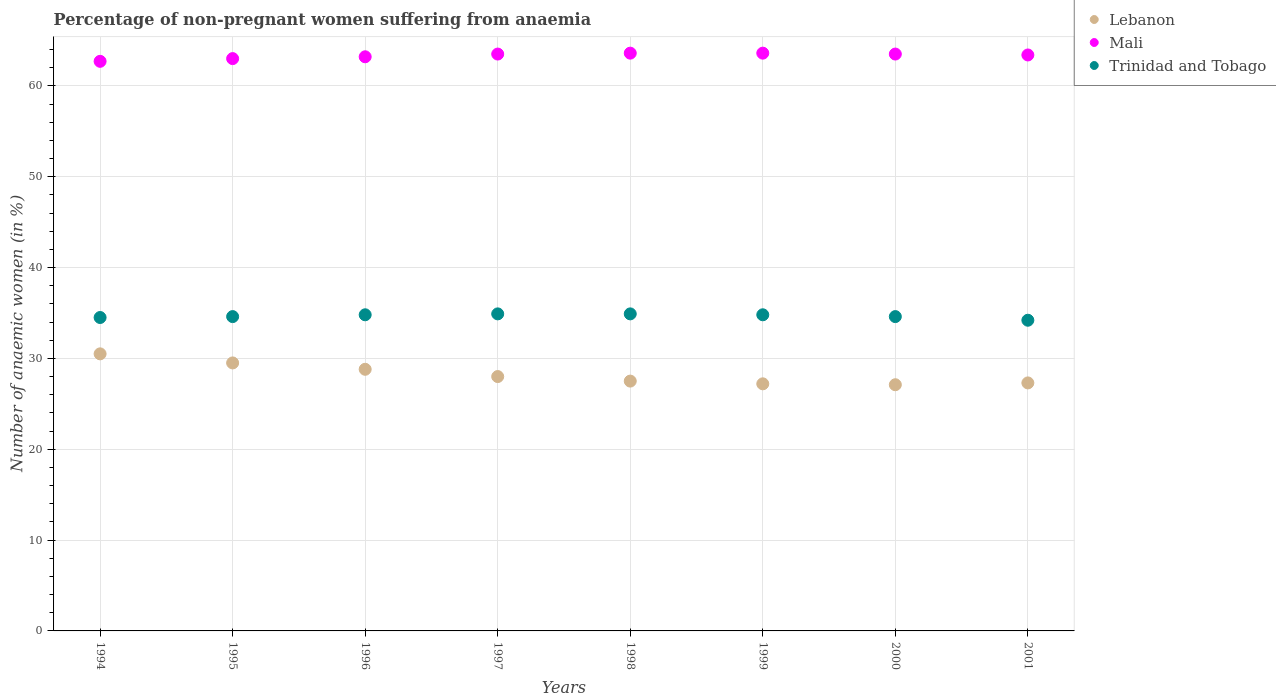What is the percentage of non-pregnant women suffering from anaemia in Lebanon in 2001?
Your response must be concise. 27.3. Across all years, what is the maximum percentage of non-pregnant women suffering from anaemia in Lebanon?
Provide a succinct answer. 30.5. Across all years, what is the minimum percentage of non-pregnant women suffering from anaemia in Trinidad and Tobago?
Ensure brevity in your answer.  34.2. What is the total percentage of non-pregnant women suffering from anaemia in Mali in the graph?
Your answer should be compact. 506.5. What is the difference between the percentage of non-pregnant women suffering from anaemia in Mali in 2000 and that in 2001?
Provide a succinct answer. 0.1. What is the difference between the percentage of non-pregnant women suffering from anaemia in Mali in 1994 and the percentage of non-pregnant women suffering from anaemia in Trinidad and Tobago in 1996?
Offer a terse response. 27.9. What is the average percentage of non-pregnant women suffering from anaemia in Mali per year?
Give a very brief answer. 63.31. In the year 1998, what is the difference between the percentage of non-pregnant women suffering from anaemia in Mali and percentage of non-pregnant women suffering from anaemia in Lebanon?
Offer a very short reply. 36.1. In how many years, is the percentage of non-pregnant women suffering from anaemia in Lebanon greater than 10 %?
Provide a short and direct response. 8. What is the ratio of the percentage of non-pregnant women suffering from anaemia in Lebanon in 1995 to that in 1996?
Ensure brevity in your answer.  1.02. Is the percentage of non-pregnant women suffering from anaemia in Lebanon in 1999 less than that in 2000?
Keep it short and to the point. No. What is the difference between the highest and the second highest percentage of non-pregnant women suffering from anaemia in Mali?
Give a very brief answer. 0. What is the difference between the highest and the lowest percentage of non-pregnant women suffering from anaemia in Mali?
Your answer should be compact. 0.9. Is the sum of the percentage of non-pregnant women suffering from anaemia in Trinidad and Tobago in 1995 and 1996 greater than the maximum percentage of non-pregnant women suffering from anaemia in Lebanon across all years?
Your answer should be compact. Yes. Does the percentage of non-pregnant women suffering from anaemia in Lebanon monotonically increase over the years?
Provide a short and direct response. No. Is the percentage of non-pregnant women suffering from anaemia in Mali strictly less than the percentage of non-pregnant women suffering from anaemia in Lebanon over the years?
Your response must be concise. No. How many dotlines are there?
Provide a succinct answer. 3. How many years are there in the graph?
Keep it short and to the point. 8. Does the graph contain any zero values?
Your answer should be very brief. No. Where does the legend appear in the graph?
Provide a succinct answer. Top right. How many legend labels are there?
Ensure brevity in your answer.  3. How are the legend labels stacked?
Offer a terse response. Vertical. What is the title of the graph?
Ensure brevity in your answer.  Percentage of non-pregnant women suffering from anaemia. What is the label or title of the X-axis?
Make the answer very short. Years. What is the label or title of the Y-axis?
Offer a terse response. Number of anaemic women (in %). What is the Number of anaemic women (in %) of Lebanon in 1994?
Keep it short and to the point. 30.5. What is the Number of anaemic women (in %) in Mali in 1994?
Ensure brevity in your answer.  62.7. What is the Number of anaemic women (in %) of Trinidad and Tobago in 1994?
Offer a terse response. 34.5. What is the Number of anaemic women (in %) in Lebanon in 1995?
Your answer should be very brief. 29.5. What is the Number of anaemic women (in %) in Trinidad and Tobago in 1995?
Make the answer very short. 34.6. What is the Number of anaemic women (in %) in Lebanon in 1996?
Your response must be concise. 28.8. What is the Number of anaemic women (in %) in Mali in 1996?
Your response must be concise. 63.2. What is the Number of anaemic women (in %) in Trinidad and Tobago in 1996?
Provide a succinct answer. 34.8. What is the Number of anaemic women (in %) of Mali in 1997?
Give a very brief answer. 63.5. What is the Number of anaemic women (in %) in Trinidad and Tobago in 1997?
Your answer should be compact. 34.9. What is the Number of anaemic women (in %) of Lebanon in 1998?
Your answer should be compact. 27.5. What is the Number of anaemic women (in %) of Mali in 1998?
Give a very brief answer. 63.6. What is the Number of anaemic women (in %) of Trinidad and Tobago in 1998?
Provide a short and direct response. 34.9. What is the Number of anaemic women (in %) in Lebanon in 1999?
Provide a short and direct response. 27.2. What is the Number of anaemic women (in %) in Mali in 1999?
Provide a succinct answer. 63.6. What is the Number of anaemic women (in %) in Trinidad and Tobago in 1999?
Ensure brevity in your answer.  34.8. What is the Number of anaemic women (in %) of Lebanon in 2000?
Ensure brevity in your answer.  27.1. What is the Number of anaemic women (in %) of Mali in 2000?
Keep it short and to the point. 63.5. What is the Number of anaemic women (in %) in Trinidad and Tobago in 2000?
Keep it short and to the point. 34.6. What is the Number of anaemic women (in %) of Lebanon in 2001?
Give a very brief answer. 27.3. What is the Number of anaemic women (in %) in Mali in 2001?
Offer a terse response. 63.4. What is the Number of anaemic women (in %) in Trinidad and Tobago in 2001?
Offer a very short reply. 34.2. Across all years, what is the maximum Number of anaemic women (in %) in Lebanon?
Ensure brevity in your answer.  30.5. Across all years, what is the maximum Number of anaemic women (in %) in Mali?
Make the answer very short. 63.6. Across all years, what is the maximum Number of anaemic women (in %) in Trinidad and Tobago?
Your response must be concise. 34.9. Across all years, what is the minimum Number of anaemic women (in %) of Lebanon?
Your response must be concise. 27.1. Across all years, what is the minimum Number of anaemic women (in %) of Mali?
Ensure brevity in your answer.  62.7. Across all years, what is the minimum Number of anaemic women (in %) of Trinidad and Tobago?
Your response must be concise. 34.2. What is the total Number of anaemic women (in %) of Lebanon in the graph?
Keep it short and to the point. 225.9. What is the total Number of anaemic women (in %) in Mali in the graph?
Your answer should be compact. 506.5. What is the total Number of anaemic women (in %) of Trinidad and Tobago in the graph?
Your answer should be very brief. 277.3. What is the difference between the Number of anaemic women (in %) in Lebanon in 1994 and that in 1996?
Your answer should be very brief. 1.7. What is the difference between the Number of anaemic women (in %) in Trinidad and Tobago in 1994 and that in 1996?
Your answer should be compact. -0.3. What is the difference between the Number of anaemic women (in %) in Lebanon in 1994 and that in 1997?
Offer a very short reply. 2.5. What is the difference between the Number of anaemic women (in %) of Mali in 1994 and that in 1997?
Your response must be concise. -0.8. What is the difference between the Number of anaemic women (in %) in Trinidad and Tobago in 1994 and that in 1997?
Ensure brevity in your answer.  -0.4. What is the difference between the Number of anaemic women (in %) of Lebanon in 1994 and that in 1998?
Ensure brevity in your answer.  3. What is the difference between the Number of anaemic women (in %) of Mali in 1994 and that in 1998?
Ensure brevity in your answer.  -0.9. What is the difference between the Number of anaemic women (in %) in Lebanon in 1994 and that in 2000?
Ensure brevity in your answer.  3.4. What is the difference between the Number of anaemic women (in %) of Mali in 1994 and that in 2000?
Offer a terse response. -0.8. What is the difference between the Number of anaemic women (in %) in Trinidad and Tobago in 1994 and that in 2000?
Your answer should be compact. -0.1. What is the difference between the Number of anaemic women (in %) in Trinidad and Tobago in 1994 and that in 2001?
Your response must be concise. 0.3. What is the difference between the Number of anaemic women (in %) of Lebanon in 1995 and that in 1996?
Your answer should be very brief. 0.7. What is the difference between the Number of anaemic women (in %) in Lebanon in 1995 and that in 1997?
Provide a short and direct response. 1.5. What is the difference between the Number of anaemic women (in %) in Mali in 1995 and that in 1997?
Offer a very short reply. -0.5. What is the difference between the Number of anaemic women (in %) in Lebanon in 1995 and that in 1998?
Offer a terse response. 2. What is the difference between the Number of anaemic women (in %) in Trinidad and Tobago in 1995 and that in 1998?
Ensure brevity in your answer.  -0.3. What is the difference between the Number of anaemic women (in %) in Lebanon in 1995 and that in 1999?
Make the answer very short. 2.3. What is the difference between the Number of anaemic women (in %) in Mali in 1995 and that in 2000?
Your answer should be compact. -0.5. What is the difference between the Number of anaemic women (in %) in Trinidad and Tobago in 1995 and that in 2001?
Provide a succinct answer. 0.4. What is the difference between the Number of anaemic women (in %) of Lebanon in 1996 and that in 1997?
Keep it short and to the point. 0.8. What is the difference between the Number of anaemic women (in %) in Trinidad and Tobago in 1996 and that in 1997?
Your answer should be compact. -0.1. What is the difference between the Number of anaemic women (in %) of Mali in 1996 and that in 1998?
Give a very brief answer. -0.4. What is the difference between the Number of anaemic women (in %) in Trinidad and Tobago in 1996 and that in 1998?
Provide a succinct answer. -0.1. What is the difference between the Number of anaemic women (in %) of Mali in 1996 and that in 1999?
Ensure brevity in your answer.  -0.4. What is the difference between the Number of anaemic women (in %) of Mali in 1996 and that in 2000?
Provide a succinct answer. -0.3. What is the difference between the Number of anaemic women (in %) in Trinidad and Tobago in 1996 and that in 2000?
Offer a terse response. 0.2. What is the difference between the Number of anaemic women (in %) of Lebanon in 1997 and that in 1998?
Give a very brief answer. 0.5. What is the difference between the Number of anaemic women (in %) in Mali in 1997 and that in 1998?
Make the answer very short. -0.1. What is the difference between the Number of anaemic women (in %) of Lebanon in 1997 and that in 1999?
Your answer should be compact. 0.8. What is the difference between the Number of anaemic women (in %) of Mali in 1997 and that in 2000?
Give a very brief answer. 0. What is the difference between the Number of anaemic women (in %) of Lebanon in 1997 and that in 2001?
Your response must be concise. 0.7. What is the difference between the Number of anaemic women (in %) of Trinidad and Tobago in 1997 and that in 2001?
Make the answer very short. 0.7. What is the difference between the Number of anaemic women (in %) in Lebanon in 1998 and that in 1999?
Your answer should be compact. 0.3. What is the difference between the Number of anaemic women (in %) of Mali in 1998 and that in 2001?
Your answer should be compact. 0.2. What is the difference between the Number of anaemic women (in %) in Trinidad and Tobago in 1998 and that in 2001?
Provide a short and direct response. 0.7. What is the difference between the Number of anaemic women (in %) in Mali in 1999 and that in 2000?
Give a very brief answer. 0.1. What is the difference between the Number of anaemic women (in %) in Lebanon in 1994 and the Number of anaemic women (in %) in Mali in 1995?
Provide a short and direct response. -32.5. What is the difference between the Number of anaemic women (in %) in Mali in 1994 and the Number of anaemic women (in %) in Trinidad and Tobago in 1995?
Your response must be concise. 28.1. What is the difference between the Number of anaemic women (in %) in Lebanon in 1994 and the Number of anaemic women (in %) in Mali in 1996?
Your response must be concise. -32.7. What is the difference between the Number of anaemic women (in %) in Lebanon in 1994 and the Number of anaemic women (in %) in Trinidad and Tobago in 1996?
Offer a terse response. -4.3. What is the difference between the Number of anaemic women (in %) of Mali in 1994 and the Number of anaemic women (in %) of Trinidad and Tobago in 1996?
Offer a very short reply. 27.9. What is the difference between the Number of anaemic women (in %) of Lebanon in 1994 and the Number of anaemic women (in %) of Mali in 1997?
Your response must be concise. -33. What is the difference between the Number of anaemic women (in %) of Mali in 1994 and the Number of anaemic women (in %) of Trinidad and Tobago in 1997?
Offer a terse response. 27.8. What is the difference between the Number of anaemic women (in %) of Lebanon in 1994 and the Number of anaemic women (in %) of Mali in 1998?
Keep it short and to the point. -33.1. What is the difference between the Number of anaemic women (in %) of Lebanon in 1994 and the Number of anaemic women (in %) of Trinidad and Tobago in 1998?
Keep it short and to the point. -4.4. What is the difference between the Number of anaemic women (in %) in Mali in 1994 and the Number of anaemic women (in %) in Trinidad and Tobago in 1998?
Your response must be concise. 27.8. What is the difference between the Number of anaemic women (in %) of Lebanon in 1994 and the Number of anaemic women (in %) of Mali in 1999?
Provide a short and direct response. -33.1. What is the difference between the Number of anaemic women (in %) of Mali in 1994 and the Number of anaemic women (in %) of Trinidad and Tobago in 1999?
Your response must be concise. 27.9. What is the difference between the Number of anaemic women (in %) of Lebanon in 1994 and the Number of anaemic women (in %) of Mali in 2000?
Your answer should be compact. -33. What is the difference between the Number of anaemic women (in %) in Lebanon in 1994 and the Number of anaemic women (in %) in Trinidad and Tobago in 2000?
Make the answer very short. -4.1. What is the difference between the Number of anaemic women (in %) in Mali in 1994 and the Number of anaemic women (in %) in Trinidad and Tobago in 2000?
Provide a succinct answer. 28.1. What is the difference between the Number of anaemic women (in %) of Lebanon in 1994 and the Number of anaemic women (in %) of Mali in 2001?
Your response must be concise. -32.9. What is the difference between the Number of anaemic women (in %) in Lebanon in 1994 and the Number of anaemic women (in %) in Trinidad and Tobago in 2001?
Your answer should be compact. -3.7. What is the difference between the Number of anaemic women (in %) of Mali in 1994 and the Number of anaemic women (in %) of Trinidad and Tobago in 2001?
Make the answer very short. 28.5. What is the difference between the Number of anaemic women (in %) in Lebanon in 1995 and the Number of anaemic women (in %) in Mali in 1996?
Make the answer very short. -33.7. What is the difference between the Number of anaemic women (in %) of Mali in 1995 and the Number of anaemic women (in %) of Trinidad and Tobago in 1996?
Your answer should be compact. 28.2. What is the difference between the Number of anaemic women (in %) of Lebanon in 1995 and the Number of anaemic women (in %) of Mali in 1997?
Your response must be concise. -34. What is the difference between the Number of anaemic women (in %) of Mali in 1995 and the Number of anaemic women (in %) of Trinidad and Tobago in 1997?
Make the answer very short. 28.1. What is the difference between the Number of anaemic women (in %) of Lebanon in 1995 and the Number of anaemic women (in %) of Mali in 1998?
Provide a succinct answer. -34.1. What is the difference between the Number of anaemic women (in %) of Lebanon in 1995 and the Number of anaemic women (in %) of Trinidad and Tobago in 1998?
Offer a terse response. -5.4. What is the difference between the Number of anaemic women (in %) of Mali in 1995 and the Number of anaemic women (in %) of Trinidad and Tobago in 1998?
Your response must be concise. 28.1. What is the difference between the Number of anaemic women (in %) of Lebanon in 1995 and the Number of anaemic women (in %) of Mali in 1999?
Ensure brevity in your answer.  -34.1. What is the difference between the Number of anaemic women (in %) of Lebanon in 1995 and the Number of anaemic women (in %) of Trinidad and Tobago in 1999?
Provide a short and direct response. -5.3. What is the difference between the Number of anaemic women (in %) of Mali in 1995 and the Number of anaemic women (in %) of Trinidad and Tobago in 1999?
Provide a succinct answer. 28.2. What is the difference between the Number of anaemic women (in %) of Lebanon in 1995 and the Number of anaemic women (in %) of Mali in 2000?
Offer a terse response. -34. What is the difference between the Number of anaemic women (in %) of Lebanon in 1995 and the Number of anaemic women (in %) of Trinidad and Tobago in 2000?
Offer a very short reply. -5.1. What is the difference between the Number of anaemic women (in %) in Mali in 1995 and the Number of anaemic women (in %) in Trinidad and Tobago in 2000?
Your response must be concise. 28.4. What is the difference between the Number of anaemic women (in %) of Lebanon in 1995 and the Number of anaemic women (in %) of Mali in 2001?
Your answer should be compact. -33.9. What is the difference between the Number of anaemic women (in %) in Lebanon in 1995 and the Number of anaemic women (in %) in Trinidad and Tobago in 2001?
Your answer should be compact. -4.7. What is the difference between the Number of anaemic women (in %) of Mali in 1995 and the Number of anaemic women (in %) of Trinidad and Tobago in 2001?
Keep it short and to the point. 28.8. What is the difference between the Number of anaemic women (in %) in Lebanon in 1996 and the Number of anaemic women (in %) in Mali in 1997?
Provide a succinct answer. -34.7. What is the difference between the Number of anaemic women (in %) in Mali in 1996 and the Number of anaemic women (in %) in Trinidad and Tobago in 1997?
Your response must be concise. 28.3. What is the difference between the Number of anaemic women (in %) in Lebanon in 1996 and the Number of anaemic women (in %) in Mali in 1998?
Your response must be concise. -34.8. What is the difference between the Number of anaemic women (in %) in Lebanon in 1996 and the Number of anaemic women (in %) in Trinidad and Tobago in 1998?
Provide a succinct answer. -6.1. What is the difference between the Number of anaemic women (in %) in Mali in 1996 and the Number of anaemic women (in %) in Trinidad and Tobago in 1998?
Your answer should be compact. 28.3. What is the difference between the Number of anaemic women (in %) in Lebanon in 1996 and the Number of anaemic women (in %) in Mali in 1999?
Your answer should be very brief. -34.8. What is the difference between the Number of anaemic women (in %) of Mali in 1996 and the Number of anaemic women (in %) of Trinidad and Tobago in 1999?
Your answer should be compact. 28.4. What is the difference between the Number of anaemic women (in %) of Lebanon in 1996 and the Number of anaemic women (in %) of Mali in 2000?
Provide a succinct answer. -34.7. What is the difference between the Number of anaemic women (in %) in Lebanon in 1996 and the Number of anaemic women (in %) in Trinidad and Tobago in 2000?
Provide a succinct answer. -5.8. What is the difference between the Number of anaemic women (in %) in Mali in 1996 and the Number of anaemic women (in %) in Trinidad and Tobago in 2000?
Keep it short and to the point. 28.6. What is the difference between the Number of anaemic women (in %) of Lebanon in 1996 and the Number of anaemic women (in %) of Mali in 2001?
Offer a very short reply. -34.6. What is the difference between the Number of anaemic women (in %) of Lebanon in 1996 and the Number of anaemic women (in %) of Trinidad and Tobago in 2001?
Make the answer very short. -5.4. What is the difference between the Number of anaemic women (in %) in Lebanon in 1997 and the Number of anaemic women (in %) in Mali in 1998?
Offer a terse response. -35.6. What is the difference between the Number of anaemic women (in %) in Lebanon in 1997 and the Number of anaemic women (in %) in Trinidad and Tobago in 1998?
Your answer should be compact. -6.9. What is the difference between the Number of anaemic women (in %) of Mali in 1997 and the Number of anaemic women (in %) of Trinidad and Tobago in 1998?
Your answer should be compact. 28.6. What is the difference between the Number of anaemic women (in %) in Lebanon in 1997 and the Number of anaemic women (in %) in Mali in 1999?
Make the answer very short. -35.6. What is the difference between the Number of anaemic women (in %) of Lebanon in 1997 and the Number of anaemic women (in %) of Trinidad and Tobago in 1999?
Your answer should be very brief. -6.8. What is the difference between the Number of anaemic women (in %) in Mali in 1997 and the Number of anaemic women (in %) in Trinidad and Tobago in 1999?
Offer a terse response. 28.7. What is the difference between the Number of anaemic women (in %) in Lebanon in 1997 and the Number of anaemic women (in %) in Mali in 2000?
Provide a short and direct response. -35.5. What is the difference between the Number of anaemic women (in %) in Lebanon in 1997 and the Number of anaemic women (in %) in Trinidad and Tobago in 2000?
Your response must be concise. -6.6. What is the difference between the Number of anaemic women (in %) of Mali in 1997 and the Number of anaemic women (in %) of Trinidad and Tobago in 2000?
Give a very brief answer. 28.9. What is the difference between the Number of anaemic women (in %) in Lebanon in 1997 and the Number of anaemic women (in %) in Mali in 2001?
Your answer should be very brief. -35.4. What is the difference between the Number of anaemic women (in %) in Mali in 1997 and the Number of anaemic women (in %) in Trinidad and Tobago in 2001?
Provide a short and direct response. 29.3. What is the difference between the Number of anaemic women (in %) in Lebanon in 1998 and the Number of anaemic women (in %) in Mali in 1999?
Keep it short and to the point. -36.1. What is the difference between the Number of anaemic women (in %) in Mali in 1998 and the Number of anaemic women (in %) in Trinidad and Tobago in 1999?
Ensure brevity in your answer.  28.8. What is the difference between the Number of anaemic women (in %) in Lebanon in 1998 and the Number of anaemic women (in %) in Mali in 2000?
Your response must be concise. -36. What is the difference between the Number of anaemic women (in %) of Lebanon in 1998 and the Number of anaemic women (in %) of Trinidad and Tobago in 2000?
Your response must be concise. -7.1. What is the difference between the Number of anaemic women (in %) of Mali in 1998 and the Number of anaemic women (in %) of Trinidad and Tobago in 2000?
Give a very brief answer. 29. What is the difference between the Number of anaemic women (in %) of Lebanon in 1998 and the Number of anaemic women (in %) of Mali in 2001?
Offer a terse response. -35.9. What is the difference between the Number of anaemic women (in %) of Lebanon in 1998 and the Number of anaemic women (in %) of Trinidad and Tobago in 2001?
Make the answer very short. -6.7. What is the difference between the Number of anaemic women (in %) of Mali in 1998 and the Number of anaemic women (in %) of Trinidad and Tobago in 2001?
Your answer should be compact. 29.4. What is the difference between the Number of anaemic women (in %) of Lebanon in 1999 and the Number of anaemic women (in %) of Mali in 2000?
Your answer should be compact. -36.3. What is the difference between the Number of anaemic women (in %) of Lebanon in 1999 and the Number of anaemic women (in %) of Trinidad and Tobago in 2000?
Keep it short and to the point. -7.4. What is the difference between the Number of anaemic women (in %) of Lebanon in 1999 and the Number of anaemic women (in %) of Mali in 2001?
Your answer should be compact. -36.2. What is the difference between the Number of anaemic women (in %) in Mali in 1999 and the Number of anaemic women (in %) in Trinidad and Tobago in 2001?
Keep it short and to the point. 29.4. What is the difference between the Number of anaemic women (in %) in Lebanon in 2000 and the Number of anaemic women (in %) in Mali in 2001?
Your response must be concise. -36.3. What is the difference between the Number of anaemic women (in %) of Mali in 2000 and the Number of anaemic women (in %) of Trinidad and Tobago in 2001?
Provide a short and direct response. 29.3. What is the average Number of anaemic women (in %) in Lebanon per year?
Your response must be concise. 28.24. What is the average Number of anaemic women (in %) of Mali per year?
Keep it short and to the point. 63.31. What is the average Number of anaemic women (in %) of Trinidad and Tobago per year?
Ensure brevity in your answer.  34.66. In the year 1994, what is the difference between the Number of anaemic women (in %) of Lebanon and Number of anaemic women (in %) of Mali?
Provide a short and direct response. -32.2. In the year 1994, what is the difference between the Number of anaemic women (in %) of Lebanon and Number of anaemic women (in %) of Trinidad and Tobago?
Give a very brief answer. -4. In the year 1994, what is the difference between the Number of anaemic women (in %) in Mali and Number of anaemic women (in %) in Trinidad and Tobago?
Ensure brevity in your answer.  28.2. In the year 1995, what is the difference between the Number of anaemic women (in %) in Lebanon and Number of anaemic women (in %) in Mali?
Your answer should be compact. -33.5. In the year 1995, what is the difference between the Number of anaemic women (in %) of Mali and Number of anaemic women (in %) of Trinidad and Tobago?
Make the answer very short. 28.4. In the year 1996, what is the difference between the Number of anaemic women (in %) of Lebanon and Number of anaemic women (in %) of Mali?
Your answer should be compact. -34.4. In the year 1996, what is the difference between the Number of anaemic women (in %) of Lebanon and Number of anaemic women (in %) of Trinidad and Tobago?
Offer a very short reply. -6. In the year 1996, what is the difference between the Number of anaemic women (in %) in Mali and Number of anaemic women (in %) in Trinidad and Tobago?
Offer a very short reply. 28.4. In the year 1997, what is the difference between the Number of anaemic women (in %) of Lebanon and Number of anaemic women (in %) of Mali?
Give a very brief answer. -35.5. In the year 1997, what is the difference between the Number of anaemic women (in %) of Mali and Number of anaemic women (in %) of Trinidad and Tobago?
Ensure brevity in your answer.  28.6. In the year 1998, what is the difference between the Number of anaemic women (in %) in Lebanon and Number of anaemic women (in %) in Mali?
Make the answer very short. -36.1. In the year 1998, what is the difference between the Number of anaemic women (in %) of Mali and Number of anaemic women (in %) of Trinidad and Tobago?
Provide a short and direct response. 28.7. In the year 1999, what is the difference between the Number of anaemic women (in %) in Lebanon and Number of anaemic women (in %) in Mali?
Make the answer very short. -36.4. In the year 1999, what is the difference between the Number of anaemic women (in %) of Lebanon and Number of anaemic women (in %) of Trinidad and Tobago?
Your response must be concise. -7.6. In the year 1999, what is the difference between the Number of anaemic women (in %) of Mali and Number of anaemic women (in %) of Trinidad and Tobago?
Offer a terse response. 28.8. In the year 2000, what is the difference between the Number of anaemic women (in %) of Lebanon and Number of anaemic women (in %) of Mali?
Keep it short and to the point. -36.4. In the year 2000, what is the difference between the Number of anaemic women (in %) in Lebanon and Number of anaemic women (in %) in Trinidad and Tobago?
Make the answer very short. -7.5. In the year 2000, what is the difference between the Number of anaemic women (in %) of Mali and Number of anaemic women (in %) of Trinidad and Tobago?
Offer a terse response. 28.9. In the year 2001, what is the difference between the Number of anaemic women (in %) in Lebanon and Number of anaemic women (in %) in Mali?
Ensure brevity in your answer.  -36.1. In the year 2001, what is the difference between the Number of anaemic women (in %) of Lebanon and Number of anaemic women (in %) of Trinidad and Tobago?
Your response must be concise. -6.9. In the year 2001, what is the difference between the Number of anaemic women (in %) in Mali and Number of anaemic women (in %) in Trinidad and Tobago?
Your response must be concise. 29.2. What is the ratio of the Number of anaemic women (in %) in Lebanon in 1994 to that in 1995?
Your response must be concise. 1.03. What is the ratio of the Number of anaemic women (in %) of Trinidad and Tobago in 1994 to that in 1995?
Provide a short and direct response. 1. What is the ratio of the Number of anaemic women (in %) in Lebanon in 1994 to that in 1996?
Offer a very short reply. 1.06. What is the ratio of the Number of anaemic women (in %) of Trinidad and Tobago in 1994 to that in 1996?
Give a very brief answer. 0.99. What is the ratio of the Number of anaemic women (in %) of Lebanon in 1994 to that in 1997?
Your answer should be very brief. 1.09. What is the ratio of the Number of anaemic women (in %) of Mali in 1994 to that in 1997?
Your response must be concise. 0.99. What is the ratio of the Number of anaemic women (in %) of Trinidad and Tobago in 1994 to that in 1997?
Your answer should be very brief. 0.99. What is the ratio of the Number of anaemic women (in %) of Lebanon in 1994 to that in 1998?
Give a very brief answer. 1.11. What is the ratio of the Number of anaemic women (in %) of Mali in 1994 to that in 1998?
Your response must be concise. 0.99. What is the ratio of the Number of anaemic women (in %) of Trinidad and Tobago in 1994 to that in 1998?
Your answer should be compact. 0.99. What is the ratio of the Number of anaemic women (in %) in Lebanon in 1994 to that in 1999?
Your response must be concise. 1.12. What is the ratio of the Number of anaemic women (in %) in Mali in 1994 to that in 1999?
Your answer should be compact. 0.99. What is the ratio of the Number of anaemic women (in %) of Lebanon in 1994 to that in 2000?
Make the answer very short. 1.13. What is the ratio of the Number of anaemic women (in %) in Mali in 1994 to that in 2000?
Offer a very short reply. 0.99. What is the ratio of the Number of anaemic women (in %) in Lebanon in 1994 to that in 2001?
Your response must be concise. 1.12. What is the ratio of the Number of anaemic women (in %) in Mali in 1994 to that in 2001?
Your answer should be compact. 0.99. What is the ratio of the Number of anaemic women (in %) in Trinidad and Tobago in 1994 to that in 2001?
Your answer should be compact. 1.01. What is the ratio of the Number of anaemic women (in %) in Lebanon in 1995 to that in 1996?
Ensure brevity in your answer.  1.02. What is the ratio of the Number of anaemic women (in %) of Lebanon in 1995 to that in 1997?
Your answer should be compact. 1.05. What is the ratio of the Number of anaemic women (in %) of Mali in 1995 to that in 1997?
Ensure brevity in your answer.  0.99. What is the ratio of the Number of anaemic women (in %) in Trinidad and Tobago in 1995 to that in 1997?
Keep it short and to the point. 0.99. What is the ratio of the Number of anaemic women (in %) of Lebanon in 1995 to that in 1998?
Offer a terse response. 1.07. What is the ratio of the Number of anaemic women (in %) of Mali in 1995 to that in 1998?
Your answer should be compact. 0.99. What is the ratio of the Number of anaemic women (in %) in Trinidad and Tobago in 1995 to that in 1998?
Your answer should be compact. 0.99. What is the ratio of the Number of anaemic women (in %) in Lebanon in 1995 to that in 1999?
Your response must be concise. 1.08. What is the ratio of the Number of anaemic women (in %) of Mali in 1995 to that in 1999?
Give a very brief answer. 0.99. What is the ratio of the Number of anaemic women (in %) in Trinidad and Tobago in 1995 to that in 1999?
Offer a terse response. 0.99. What is the ratio of the Number of anaemic women (in %) of Lebanon in 1995 to that in 2000?
Your response must be concise. 1.09. What is the ratio of the Number of anaemic women (in %) in Mali in 1995 to that in 2000?
Your answer should be very brief. 0.99. What is the ratio of the Number of anaemic women (in %) of Lebanon in 1995 to that in 2001?
Provide a short and direct response. 1.08. What is the ratio of the Number of anaemic women (in %) of Mali in 1995 to that in 2001?
Provide a succinct answer. 0.99. What is the ratio of the Number of anaemic women (in %) of Trinidad and Tobago in 1995 to that in 2001?
Keep it short and to the point. 1.01. What is the ratio of the Number of anaemic women (in %) of Lebanon in 1996 to that in 1997?
Offer a very short reply. 1.03. What is the ratio of the Number of anaemic women (in %) in Mali in 1996 to that in 1997?
Give a very brief answer. 1. What is the ratio of the Number of anaemic women (in %) in Lebanon in 1996 to that in 1998?
Provide a short and direct response. 1.05. What is the ratio of the Number of anaemic women (in %) of Trinidad and Tobago in 1996 to that in 1998?
Offer a terse response. 1. What is the ratio of the Number of anaemic women (in %) in Lebanon in 1996 to that in 1999?
Your response must be concise. 1.06. What is the ratio of the Number of anaemic women (in %) in Mali in 1996 to that in 1999?
Offer a terse response. 0.99. What is the ratio of the Number of anaemic women (in %) in Lebanon in 1996 to that in 2000?
Your answer should be compact. 1.06. What is the ratio of the Number of anaemic women (in %) in Lebanon in 1996 to that in 2001?
Make the answer very short. 1.05. What is the ratio of the Number of anaemic women (in %) in Mali in 1996 to that in 2001?
Offer a terse response. 1. What is the ratio of the Number of anaemic women (in %) in Trinidad and Tobago in 1996 to that in 2001?
Your answer should be compact. 1.02. What is the ratio of the Number of anaemic women (in %) of Lebanon in 1997 to that in 1998?
Offer a terse response. 1.02. What is the ratio of the Number of anaemic women (in %) of Trinidad and Tobago in 1997 to that in 1998?
Provide a short and direct response. 1. What is the ratio of the Number of anaemic women (in %) of Lebanon in 1997 to that in 1999?
Ensure brevity in your answer.  1.03. What is the ratio of the Number of anaemic women (in %) in Trinidad and Tobago in 1997 to that in 1999?
Provide a short and direct response. 1. What is the ratio of the Number of anaemic women (in %) in Lebanon in 1997 to that in 2000?
Your response must be concise. 1.03. What is the ratio of the Number of anaemic women (in %) of Trinidad and Tobago in 1997 to that in 2000?
Offer a terse response. 1.01. What is the ratio of the Number of anaemic women (in %) in Lebanon in 1997 to that in 2001?
Your answer should be very brief. 1.03. What is the ratio of the Number of anaemic women (in %) of Trinidad and Tobago in 1997 to that in 2001?
Ensure brevity in your answer.  1.02. What is the ratio of the Number of anaemic women (in %) in Mali in 1998 to that in 1999?
Your answer should be very brief. 1. What is the ratio of the Number of anaemic women (in %) of Trinidad and Tobago in 1998 to that in 1999?
Your answer should be very brief. 1. What is the ratio of the Number of anaemic women (in %) in Lebanon in 1998 to that in 2000?
Your response must be concise. 1.01. What is the ratio of the Number of anaemic women (in %) in Trinidad and Tobago in 1998 to that in 2000?
Provide a short and direct response. 1.01. What is the ratio of the Number of anaemic women (in %) in Lebanon in 1998 to that in 2001?
Your answer should be very brief. 1.01. What is the ratio of the Number of anaemic women (in %) in Trinidad and Tobago in 1998 to that in 2001?
Provide a succinct answer. 1.02. What is the ratio of the Number of anaemic women (in %) in Mali in 1999 to that in 2000?
Provide a short and direct response. 1. What is the ratio of the Number of anaemic women (in %) of Trinidad and Tobago in 1999 to that in 2000?
Ensure brevity in your answer.  1.01. What is the ratio of the Number of anaemic women (in %) in Mali in 1999 to that in 2001?
Your response must be concise. 1. What is the ratio of the Number of anaemic women (in %) of Trinidad and Tobago in 1999 to that in 2001?
Provide a short and direct response. 1.02. What is the ratio of the Number of anaemic women (in %) in Trinidad and Tobago in 2000 to that in 2001?
Your answer should be very brief. 1.01. What is the difference between the highest and the second highest Number of anaemic women (in %) of Lebanon?
Keep it short and to the point. 1. What is the difference between the highest and the second highest Number of anaemic women (in %) in Mali?
Keep it short and to the point. 0. What is the difference between the highest and the lowest Number of anaemic women (in %) in Lebanon?
Your answer should be very brief. 3.4. What is the difference between the highest and the lowest Number of anaemic women (in %) in Trinidad and Tobago?
Offer a very short reply. 0.7. 